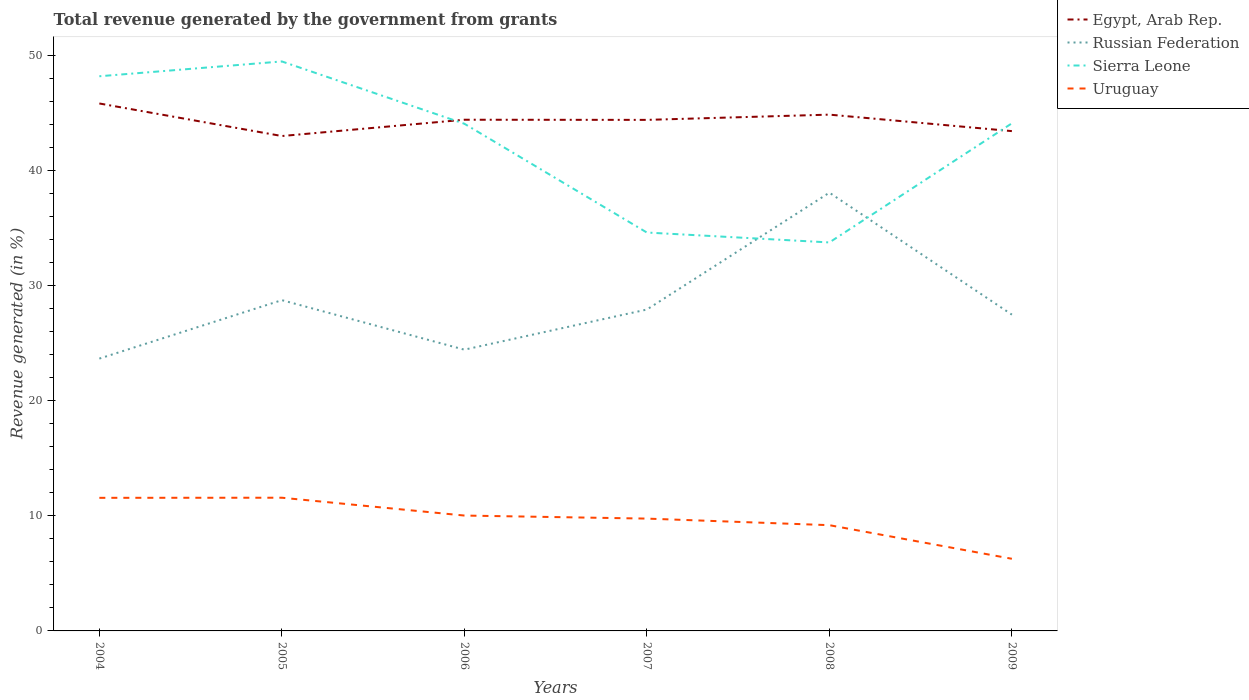Does the line corresponding to Uruguay intersect with the line corresponding to Russian Federation?
Keep it short and to the point. No. Across all years, what is the maximum total revenue generated in Egypt, Arab Rep.?
Provide a short and direct response. 43.01. What is the total total revenue generated in Sierra Leone in the graph?
Your answer should be compact. 9.45. What is the difference between the highest and the second highest total revenue generated in Sierra Leone?
Your answer should be very brief. 15.73. Is the total revenue generated in Sierra Leone strictly greater than the total revenue generated in Egypt, Arab Rep. over the years?
Ensure brevity in your answer.  No. How many lines are there?
Provide a short and direct response. 4. What is the difference between two consecutive major ticks on the Y-axis?
Your answer should be very brief. 10. Does the graph contain grids?
Provide a succinct answer. No. Where does the legend appear in the graph?
Provide a succinct answer. Top right. How many legend labels are there?
Give a very brief answer. 4. How are the legend labels stacked?
Make the answer very short. Vertical. What is the title of the graph?
Offer a very short reply. Total revenue generated by the government from grants. Does "Mali" appear as one of the legend labels in the graph?
Keep it short and to the point. No. What is the label or title of the X-axis?
Ensure brevity in your answer.  Years. What is the label or title of the Y-axis?
Your answer should be compact. Revenue generated (in %). What is the Revenue generated (in %) of Egypt, Arab Rep. in 2004?
Your response must be concise. 45.83. What is the Revenue generated (in %) of Russian Federation in 2004?
Keep it short and to the point. 23.66. What is the Revenue generated (in %) of Sierra Leone in 2004?
Provide a short and direct response. 48.2. What is the Revenue generated (in %) in Uruguay in 2004?
Offer a terse response. 11.57. What is the Revenue generated (in %) of Egypt, Arab Rep. in 2005?
Ensure brevity in your answer.  43.01. What is the Revenue generated (in %) in Russian Federation in 2005?
Your response must be concise. 28.74. What is the Revenue generated (in %) of Sierra Leone in 2005?
Your response must be concise. 49.49. What is the Revenue generated (in %) in Uruguay in 2005?
Keep it short and to the point. 11.58. What is the Revenue generated (in %) in Egypt, Arab Rep. in 2006?
Your answer should be compact. 44.42. What is the Revenue generated (in %) of Russian Federation in 2006?
Make the answer very short. 24.44. What is the Revenue generated (in %) in Sierra Leone in 2006?
Your answer should be very brief. 44.07. What is the Revenue generated (in %) of Uruguay in 2006?
Ensure brevity in your answer.  10.03. What is the Revenue generated (in %) of Egypt, Arab Rep. in 2007?
Offer a terse response. 44.41. What is the Revenue generated (in %) in Russian Federation in 2007?
Ensure brevity in your answer.  27.93. What is the Revenue generated (in %) of Sierra Leone in 2007?
Offer a terse response. 34.62. What is the Revenue generated (in %) in Uruguay in 2007?
Provide a succinct answer. 9.76. What is the Revenue generated (in %) of Egypt, Arab Rep. in 2008?
Provide a succinct answer. 44.87. What is the Revenue generated (in %) of Russian Federation in 2008?
Make the answer very short. 38.08. What is the Revenue generated (in %) in Sierra Leone in 2008?
Offer a very short reply. 33.76. What is the Revenue generated (in %) of Uruguay in 2008?
Your response must be concise. 9.19. What is the Revenue generated (in %) in Egypt, Arab Rep. in 2009?
Your answer should be compact. 43.43. What is the Revenue generated (in %) in Russian Federation in 2009?
Provide a short and direct response. 27.48. What is the Revenue generated (in %) in Sierra Leone in 2009?
Make the answer very short. 44.11. What is the Revenue generated (in %) of Uruguay in 2009?
Offer a terse response. 6.27. Across all years, what is the maximum Revenue generated (in %) of Egypt, Arab Rep.?
Ensure brevity in your answer.  45.83. Across all years, what is the maximum Revenue generated (in %) in Russian Federation?
Provide a succinct answer. 38.08. Across all years, what is the maximum Revenue generated (in %) of Sierra Leone?
Offer a very short reply. 49.49. Across all years, what is the maximum Revenue generated (in %) in Uruguay?
Provide a short and direct response. 11.58. Across all years, what is the minimum Revenue generated (in %) in Egypt, Arab Rep.?
Your response must be concise. 43.01. Across all years, what is the minimum Revenue generated (in %) of Russian Federation?
Your answer should be compact. 23.66. Across all years, what is the minimum Revenue generated (in %) in Sierra Leone?
Provide a short and direct response. 33.76. Across all years, what is the minimum Revenue generated (in %) of Uruguay?
Make the answer very short. 6.27. What is the total Revenue generated (in %) of Egypt, Arab Rep. in the graph?
Provide a succinct answer. 265.97. What is the total Revenue generated (in %) in Russian Federation in the graph?
Your answer should be very brief. 170.35. What is the total Revenue generated (in %) of Sierra Leone in the graph?
Make the answer very short. 254.25. What is the total Revenue generated (in %) in Uruguay in the graph?
Make the answer very short. 58.39. What is the difference between the Revenue generated (in %) in Egypt, Arab Rep. in 2004 and that in 2005?
Offer a terse response. 2.83. What is the difference between the Revenue generated (in %) of Russian Federation in 2004 and that in 2005?
Ensure brevity in your answer.  -5.08. What is the difference between the Revenue generated (in %) in Sierra Leone in 2004 and that in 2005?
Make the answer very short. -1.29. What is the difference between the Revenue generated (in %) in Uruguay in 2004 and that in 2005?
Make the answer very short. -0.01. What is the difference between the Revenue generated (in %) in Egypt, Arab Rep. in 2004 and that in 2006?
Your answer should be compact. 1.41. What is the difference between the Revenue generated (in %) in Russian Federation in 2004 and that in 2006?
Provide a short and direct response. -0.78. What is the difference between the Revenue generated (in %) of Sierra Leone in 2004 and that in 2006?
Offer a terse response. 4.13. What is the difference between the Revenue generated (in %) in Uruguay in 2004 and that in 2006?
Your answer should be very brief. 1.54. What is the difference between the Revenue generated (in %) of Egypt, Arab Rep. in 2004 and that in 2007?
Offer a terse response. 1.43. What is the difference between the Revenue generated (in %) of Russian Federation in 2004 and that in 2007?
Ensure brevity in your answer.  -4.26. What is the difference between the Revenue generated (in %) of Sierra Leone in 2004 and that in 2007?
Ensure brevity in your answer.  13.58. What is the difference between the Revenue generated (in %) in Uruguay in 2004 and that in 2007?
Provide a succinct answer. 1.81. What is the difference between the Revenue generated (in %) in Egypt, Arab Rep. in 2004 and that in 2008?
Your answer should be very brief. 0.97. What is the difference between the Revenue generated (in %) of Russian Federation in 2004 and that in 2008?
Your response must be concise. -14.42. What is the difference between the Revenue generated (in %) of Sierra Leone in 2004 and that in 2008?
Provide a short and direct response. 14.44. What is the difference between the Revenue generated (in %) of Uruguay in 2004 and that in 2008?
Your answer should be compact. 2.38. What is the difference between the Revenue generated (in %) of Egypt, Arab Rep. in 2004 and that in 2009?
Ensure brevity in your answer.  2.4. What is the difference between the Revenue generated (in %) in Russian Federation in 2004 and that in 2009?
Your response must be concise. -3.82. What is the difference between the Revenue generated (in %) in Sierra Leone in 2004 and that in 2009?
Keep it short and to the point. 4.09. What is the difference between the Revenue generated (in %) in Uruguay in 2004 and that in 2009?
Offer a very short reply. 5.3. What is the difference between the Revenue generated (in %) in Egypt, Arab Rep. in 2005 and that in 2006?
Ensure brevity in your answer.  -1.42. What is the difference between the Revenue generated (in %) in Russian Federation in 2005 and that in 2006?
Provide a short and direct response. 4.3. What is the difference between the Revenue generated (in %) in Sierra Leone in 2005 and that in 2006?
Give a very brief answer. 5.41. What is the difference between the Revenue generated (in %) in Uruguay in 2005 and that in 2006?
Offer a terse response. 1.55. What is the difference between the Revenue generated (in %) in Egypt, Arab Rep. in 2005 and that in 2007?
Your answer should be compact. -1.4. What is the difference between the Revenue generated (in %) in Russian Federation in 2005 and that in 2007?
Offer a very short reply. 0.82. What is the difference between the Revenue generated (in %) of Sierra Leone in 2005 and that in 2007?
Your answer should be compact. 14.87. What is the difference between the Revenue generated (in %) in Uruguay in 2005 and that in 2007?
Offer a very short reply. 1.81. What is the difference between the Revenue generated (in %) in Egypt, Arab Rep. in 2005 and that in 2008?
Your answer should be compact. -1.86. What is the difference between the Revenue generated (in %) of Russian Federation in 2005 and that in 2008?
Provide a succinct answer. -9.34. What is the difference between the Revenue generated (in %) of Sierra Leone in 2005 and that in 2008?
Provide a short and direct response. 15.73. What is the difference between the Revenue generated (in %) in Uruguay in 2005 and that in 2008?
Make the answer very short. 2.39. What is the difference between the Revenue generated (in %) of Egypt, Arab Rep. in 2005 and that in 2009?
Provide a short and direct response. -0.43. What is the difference between the Revenue generated (in %) of Russian Federation in 2005 and that in 2009?
Provide a short and direct response. 1.26. What is the difference between the Revenue generated (in %) of Sierra Leone in 2005 and that in 2009?
Provide a succinct answer. 5.38. What is the difference between the Revenue generated (in %) of Uruguay in 2005 and that in 2009?
Provide a short and direct response. 5.31. What is the difference between the Revenue generated (in %) of Egypt, Arab Rep. in 2006 and that in 2007?
Give a very brief answer. 0.01. What is the difference between the Revenue generated (in %) in Russian Federation in 2006 and that in 2007?
Keep it short and to the point. -3.49. What is the difference between the Revenue generated (in %) in Sierra Leone in 2006 and that in 2007?
Provide a short and direct response. 9.45. What is the difference between the Revenue generated (in %) in Uruguay in 2006 and that in 2007?
Keep it short and to the point. 0.27. What is the difference between the Revenue generated (in %) in Egypt, Arab Rep. in 2006 and that in 2008?
Ensure brevity in your answer.  -0.44. What is the difference between the Revenue generated (in %) of Russian Federation in 2006 and that in 2008?
Ensure brevity in your answer.  -13.64. What is the difference between the Revenue generated (in %) in Sierra Leone in 2006 and that in 2008?
Keep it short and to the point. 10.32. What is the difference between the Revenue generated (in %) of Uruguay in 2006 and that in 2008?
Provide a short and direct response. 0.84. What is the difference between the Revenue generated (in %) in Egypt, Arab Rep. in 2006 and that in 2009?
Provide a short and direct response. 0.99. What is the difference between the Revenue generated (in %) in Russian Federation in 2006 and that in 2009?
Ensure brevity in your answer.  -3.04. What is the difference between the Revenue generated (in %) of Sierra Leone in 2006 and that in 2009?
Your answer should be compact. -0.04. What is the difference between the Revenue generated (in %) in Uruguay in 2006 and that in 2009?
Your answer should be very brief. 3.76. What is the difference between the Revenue generated (in %) of Egypt, Arab Rep. in 2007 and that in 2008?
Your response must be concise. -0.46. What is the difference between the Revenue generated (in %) of Russian Federation in 2007 and that in 2008?
Make the answer very short. -10.16. What is the difference between the Revenue generated (in %) in Sierra Leone in 2007 and that in 2008?
Make the answer very short. 0.86. What is the difference between the Revenue generated (in %) of Uruguay in 2007 and that in 2008?
Provide a short and direct response. 0.57. What is the difference between the Revenue generated (in %) in Egypt, Arab Rep. in 2007 and that in 2009?
Ensure brevity in your answer.  0.98. What is the difference between the Revenue generated (in %) in Russian Federation in 2007 and that in 2009?
Offer a terse response. 0.44. What is the difference between the Revenue generated (in %) of Sierra Leone in 2007 and that in 2009?
Provide a short and direct response. -9.49. What is the difference between the Revenue generated (in %) in Uruguay in 2007 and that in 2009?
Give a very brief answer. 3.49. What is the difference between the Revenue generated (in %) of Egypt, Arab Rep. in 2008 and that in 2009?
Give a very brief answer. 1.43. What is the difference between the Revenue generated (in %) in Russian Federation in 2008 and that in 2009?
Provide a succinct answer. 10.6. What is the difference between the Revenue generated (in %) of Sierra Leone in 2008 and that in 2009?
Give a very brief answer. -10.35. What is the difference between the Revenue generated (in %) of Uruguay in 2008 and that in 2009?
Keep it short and to the point. 2.92. What is the difference between the Revenue generated (in %) of Egypt, Arab Rep. in 2004 and the Revenue generated (in %) of Russian Federation in 2005?
Your response must be concise. 17.09. What is the difference between the Revenue generated (in %) of Egypt, Arab Rep. in 2004 and the Revenue generated (in %) of Sierra Leone in 2005?
Make the answer very short. -3.65. What is the difference between the Revenue generated (in %) in Egypt, Arab Rep. in 2004 and the Revenue generated (in %) in Uruguay in 2005?
Ensure brevity in your answer.  34.26. What is the difference between the Revenue generated (in %) of Russian Federation in 2004 and the Revenue generated (in %) of Sierra Leone in 2005?
Give a very brief answer. -25.82. What is the difference between the Revenue generated (in %) in Russian Federation in 2004 and the Revenue generated (in %) in Uruguay in 2005?
Offer a terse response. 12.09. What is the difference between the Revenue generated (in %) of Sierra Leone in 2004 and the Revenue generated (in %) of Uruguay in 2005?
Give a very brief answer. 36.62. What is the difference between the Revenue generated (in %) in Egypt, Arab Rep. in 2004 and the Revenue generated (in %) in Russian Federation in 2006?
Offer a very short reply. 21.39. What is the difference between the Revenue generated (in %) in Egypt, Arab Rep. in 2004 and the Revenue generated (in %) in Sierra Leone in 2006?
Ensure brevity in your answer.  1.76. What is the difference between the Revenue generated (in %) in Egypt, Arab Rep. in 2004 and the Revenue generated (in %) in Uruguay in 2006?
Your answer should be very brief. 35.81. What is the difference between the Revenue generated (in %) in Russian Federation in 2004 and the Revenue generated (in %) in Sierra Leone in 2006?
Offer a very short reply. -20.41. What is the difference between the Revenue generated (in %) of Russian Federation in 2004 and the Revenue generated (in %) of Uruguay in 2006?
Your response must be concise. 13.64. What is the difference between the Revenue generated (in %) in Sierra Leone in 2004 and the Revenue generated (in %) in Uruguay in 2006?
Your response must be concise. 38.17. What is the difference between the Revenue generated (in %) in Egypt, Arab Rep. in 2004 and the Revenue generated (in %) in Russian Federation in 2007?
Your answer should be very brief. 17.91. What is the difference between the Revenue generated (in %) of Egypt, Arab Rep. in 2004 and the Revenue generated (in %) of Sierra Leone in 2007?
Your answer should be compact. 11.21. What is the difference between the Revenue generated (in %) of Egypt, Arab Rep. in 2004 and the Revenue generated (in %) of Uruguay in 2007?
Your response must be concise. 36.07. What is the difference between the Revenue generated (in %) in Russian Federation in 2004 and the Revenue generated (in %) in Sierra Leone in 2007?
Offer a terse response. -10.96. What is the difference between the Revenue generated (in %) of Russian Federation in 2004 and the Revenue generated (in %) of Uruguay in 2007?
Your answer should be compact. 13.9. What is the difference between the Revenue generated (in %) of Sierra Leone in 2004 and the Revenue generated (in %) of Uruguay in 2007?
Provide a short and direct response. 38.44. What is the difference between the Revenue generated (in %) of Egypt, Arab Rep. in 2004 and the Revenue generated (in %) of Russian Federation in 2008?
Make the answer very short. 7.75. What is the difference between the Revenue generated (in %) in Egypt, Arab Rep. in 2004 and the Revenue generated (in %) in Sierra Leone in 2008?
Keep it short and to the point. 12.08. What is the difference between the Revenue generated (in %) in Egypt, Arab Rep. in 2004 and the Revenue generated (in %) in Uruguay in 2008?
Keep it short and to the point. 36.64. What is the difference between the Revenue generated (in %) of Russian Federation in 2004 and the Revenue generated (in %) of Sierra Leone in 2008?
Make the answer very short. -10.09. What is the difference between the Revenue generated (in %) in Russian Federation in 2004 and the Revenue generated (in %) in Uruguay in 2008?
Offer a terse response. 14.48. What is the difference between the Revenue generated (in %) of Sierra Leone in 2004 and the Revenue generated (in %) of Uruguay in 2008?
Your answer should be very brief. 39.01. What is the difference between the Revenue generated (in %) of Egypt, Arab Rep. in 2004 and the Revenue generated (in %) of Russian Federation in 2009?
Your answer should be compact. 18.35. What is the difference between the Revenue generated (in %) in Egypt, Arab Rep. in 2004 and the Revenue generated (in %) in Sierra Leone in 2009?
Keep it short and to the point. 1.72. What is the difference between the Revenue generated (in %) of Egypt, Arab Rep. in 2004 and the Revenue generated (in %) of Uruguay in 2009?
Make the answer very short. 39.57. What is the difference between the Revenue generated (in %) in Russian Federation in 2004 and the Revenue generated (in %) in Sierra Leone in 2009?
Offer a very short reply. -20.45. What is the difference between the Revenue generated (in %) of Russian Federation in 2004 and the Revenue generated (in %) of Uruguay in 2009?
Offer a very short reply. 17.4. What is the difference between the Revenue generated (in %) in Sierra Leone in 2004 and the Revenue generated (in %) in Uruguay in 2009?
Your answer should be very brief. 41.93. What is the difference between the Revenue generated (in %) of Egypt, Arab Rep. in 2005 and the Revenue generated (in %) of Russian Federation in 2006?
Your answer should be compact. 18.56. What is the difference between the Revenue generated (in %) of Egypt, Arab Rep. in 2005 and the Revenue generated (in %) of Sierra Leone in 2006?
Ensure brevity in your answer.  -1.07. What is the difference between the Revenue generated (in %) in Egypt, Arab Rep. in 2005 and the Revenue generated (in %) in Uruguay in 2006?
Make the answer very short. 32.98. What is the difference between the Revenue generated (in %) of Russian Federation in 2005 and the Revenue generated (in %) of Sierra Leone in 2006?
Provide a succinct answer. -15.33. What is the difference between the Revenue generated (in %) of Russian Federation in 2005 and the Revenue generated (in %) of Uruguay in 2006?
Your response must be concise. 18.72. What is the difference between the Revenue generated (in %) in Sierra Leone in 2005 and the Revenue generated (in %) in Uruguay in 2006?
Keep it short and to the point. 39.46. What is the difference between the Revenue generated (in %) of Egypt, Arab Rep. in 2005 and the Revenue generated (in %) of Russian Federation in 2007?
Your response must be concise. 15.08. What is the difference between the Revenue generated (in %) of Egypt, Arab Rep. in 2005 and the Revenue generated (in %) of Sierra Leone in 2007?
Offer a very short reply. 8.39. What is the difference between the Revenue generated (in %) of Egypt, Arab Rep. in 2005 and the Revenue generated (in %) of Uruguay in 2007?
Provide a short and direct response. 33.25. What is the difference between the Revenue generated (in %) in Russian Federation in 2005 and the Revenue generated (in %) in Sierra Leone in 2007?
Offer a very short reply. -5.88. What is the difference between the Revenue generated (in %) in Russian Federation in 2005 and the Revenue generated (in %) in Uruguay in 2007?
Keep it short and to the point. 18.98. What is the difference between the Revenue generated (in %) in Sierra Leone in 2005 and the Revenue generated (in %) in Uruguay in 2007?
Offer a terse response. 39.73. What is the difference between the Revenue generated (in %) in Egypt, Arab Rep. in 2005 and the Revenue generated (in %) in Russian Federation in 2008?
Offer a terse response. 4.92. What is the difference between the Revenue generated (in %) in Egypt, Arab Rep. in 2005 and the Revenue generated (in %) in Sierra Leone in 2008?
Provide a succinct answer. 9.25. What is the difference between the Revenue generated (in %) of Egypt, Arab Rep. in 2005 and the Revenue generated (in %) of Uruguay in 2008?
Provide a short and direct response. 33.82. What is the difference between the Revenue generated (in %) in Russian Federation in 2005 and the Revenue generated (in %) in Sierra Leone in 2008?
Make the answer very short. -5.01. What is the difference between the Revenue generated (in %) of Russian Federation in 2005 and the Revenue generated (in %) of Uruguay in 2008?
Give a very brief answer. 19.55. What is the difference between the Revenue generated (in %) of Sierra Leone in 2005 and the Revenue generated (in %) of Uruguay in 2008?
Give a very brief answer. 40.3. What is the difference between the Revenue generated (in %) in Egypt, Arab Rep. in 2005 and the Revenue generated (in %) in Russian Federation in 2009?
Your answer should be very brief. 15.52. What is the difference between the Revenue generated (in %) in Egypt, Arab Rep. in 2005 and the Revenue generated (in %) in Sierra Leone in 2009?
Offer a very short reply. -1.1. What is the difference between the Revenue generated (in %) of Egypt, Arab Rep. in 2005 and the Revenue generated (in %) of Uruguay in 2009?
Offer a terse response. 36.74. What is the difference between the Revenue generated (in %) of Russian Federation in 2005 and the Revenue generated (in %) of Sierra Leone in 2009?
Offer a very short reply. -15.37. What is the difference between the Revenue generated (in %) in Russian Federation in 2005 and the Revenue generated (in %) in Uruguay in 2009?
Make the answer very short. 22.47. What is the difference between the Revenue generated (in %) of Sierra Leone in 2005 and the Revenue generated (in %) of Uruguay in 2009?
Ensure brevity in your answer.  43.22. What is the difference between the Revenue generated (in %) in Egypt, Arab Rep. in 2006 and the Revenue generated (in %) in Russian Federation in 2007?
Your response must be concise. 16.49. What is the difference between the Revenue generated (in %) of Egypt, Arab Rep. in 2006 and the Revenue generated (in %) of Sierra Leone in 2007?
Provide a succinct answer. 9.8. What is the difference between the Revenue generated (in %) in Egypt, Arab Rep. in 2006 and the Revenue generated (in %) in Uruguay in 2007?
Give a very brief answer. 34.66. What is the difference between the Revenue generated (in %) in Russian Federation in 2006 and the Revenue generated (in %) in Sierra Leone in 2007?
Give a very brief answer. -10.18. What is the difference between the Revenue generated (in %) in Russian Federation in 2006 and the Revenue generated (in %) in Uruguay in 2007?
Make the answer very short. 14.68. What is the difference between the Revenue generated (in %) of Sierra Leone in 2006 and the Revenue generated (in %) of Uruguay in 2007?
Ensure brevity in your answer.  34.31. What is the difference between the Revenue generated (in %) of Egypt, Arab Rep. in 2006 and the Revenue generated (in %) of Russian Federation in 2008?
Ensure brevity in your answer.  6.34. What is the difference between the Revenue generated (in %) in Egypt, Arab Rep. in 2006 and the Revenue generated (in %) in Sierra Leone in 2008?
Give a very brief answer. 10.66. What is the difference between the Revenue generated (in %) of Egypt, Arab Rep. in 2006 and the Revenue generated (in %) of Uruguay in 2008?
Make the answer very short. 35.23. What is the difference between the Revenue generated (in %) in Russian Federation in 2006 and the Revenue generated (in %) in Sierra Leone in 2008?
Ensure brevity in your answer.  -9.32. What is the difference between the Revenue generated (in %) in Russian Federation in 2006 and the Revenue generated (in %) in Uruguay in 2008?
Ensure brevity in your answer.  15.25. What is the difference between the Revenue generated (in %) in Sierra Leone in 2006 and the Revenue generated (in %) in Uruguay in 2008?
Ensure brevity in your answer.  34.88. What is the difference between the Revenue generated (in %) of Egypt, Arab Rep. in 2006 and the Revenue generated (in %) of Russian Federation in 2009?
Your answer should be compact. 16.94. What is the difference between the Revenue generated (in %) in Egypt, Arab Rep. in 2006 and the Revenue generated (in %) in Sierra Leone in 2009?
Keep it short and to the point. 0.31. What is the difference between the Revenue generated (in %) of Egypt, Arab Rep. in 2006 and the Revenue generated (in %) of Uruguay in 2009?
Give a very brief answer. 38.15. What is the difference between the Revenue generated (in %) of Russian Federation in 2006 and the Revenue generated (in %) of Sierra Leone in 2009?
Give a very brief answer. -19.67. What is the difference between the Revenue generated (in %) in Russian Federation in 2006 and the Revenue generated (in %) in Uruguay in 2009?
Keep it short and to the point. 18.17. What is the difference between the Revenue generated (in %) in Sierra Leone in 2006 and the Revenue generated (in %) in Uruguay in 2009?
Provide a succinct answer. 37.81. What is the difference between the Revenue generated (in %) of Egypt, Arab Rep. in 2007 and the Revenue generated (in %) of Russian Federation in 2008?
Offer a terse response. 6.33. What is the difference between the Revenue generated (in %) in Egypt, Arab Rep. in 2007 and the Revenue generated (in %) in Sierra Leone in 2008?
Ensure brevity in your answer.  10.65. What is the difference between the Revenue generated (in %) of Egypt, Arab Rep. in 2007 and the Revenue generated (in %) of Uruguay in 2008?
Make the answer very short. 35.22. What is the difference between the Revenue generated (in %) in Russian Federation in 2007 and the Revenue generated (in %) in Sierra Leone in 2008?
Your answer should be compact. -5.83. What is the difference between the Revenue generated (in %) of Russian Federation in 2007 and the Revenue generated (in %) of Uruguay in 2008?
Keep it short and to the point. 18.74. What is the difference between the Revenue generated (in %) in Sierra Leone in 2007 and the Revenue generated (in %) in Uruguay in 2008?
Offer a very short reply. 25.43. What is the difference between the Revenue generated (in %) of Egypt, Arab Rep. in 2007 and the Revenue generated (in %) of Russian Federation in 2009?
Your response must be concise. 16.92. What is the difference between the Revenue generated (in %) of Egypt, Arab Rep. in 2007 and the Revenue generated (in %) of Sierra Leone in 2009?
Offer a terse response. 0.3. What is the difference between the Revenue generated (in %) in Egypt, Arab Rep. in 2007 and the Revenue generated (in %) in Uruguay in 2009?
Your response must be concise. 38.14. What is the difference between the Revenue generated (in %) in Russian Federation in 2007 and the Revenue generated (in %) in Sierra Leone in 2009?
Your answer should be compact. -16.18. What is the difference between the Revenue generated (in %) in Russian Federation in 2007 and the Revenue generated (in %) in Uruguay in 2009?
Your answer should be compact. 21.66. What is the difference between the Revenue generated (in %) of Sierra Leone in 2007 and the Revenue generated (in %) of Uruguay in 2009?
Offer a terse response. 28.35. What is the difference between the Revenue generated (in %) in Egypt, Arab Rep. in 2008 and the Revenue generated (in %) in Russian Federation in 2009?
Give a very brief answer. 17.38. What is the difference between the Revenue generated (in %) of Egypt, Arab Rep. in 2008 and the Revenue generated (in %) of Sierra Leone in 2009?
Ensure brevity in your answer.  0.75. What is the difference between the Revenue generated (in %) of Egypt, Arab Rep. in 2008 and the Revenue generated (in %) of Uruguay in 2009?
Make the answer very short. 38.6. What is the difference between the Revenue generated (in %) of Russian Federation in 2008 and the Revenue generated (in %) of Sierra Leone in 2009?
Give a very brief answer. -6.03. What is the difference between the Revenue generated (in %) of Russian Federation in 2008 and the Revenue generated (in %) of Uruguay in 2009?
Keep it short and to the point. 31.82. What is the difference between the Revenue generated (in %) of Sierra Leone in 2008 and the Revenue generated (in %) of Uruguay in 2009?
Your answer should be compact. 27.49. What is the average Revenue generated (in %) in Egypt, Arab Rep. per year?
Your answer should be compact. 44.33. What is the average Revenue generated (in %) in Russian Federation per year?
Keep it short and to the point. 28.39. What is the average Revenue generated (in %) of Sierra Leone per year?
Your answer should be compact. 42.37. What is the average Revenue generated (in %) in Uruguay per year?
Your answer should be compact. 9.73. In the year 2004, what is the difference between the Revenue generated (in %) of Egypt, Arab Rep. and Revenue generated (in %) of Russian Federation?
Your response must be concise. 22.17. In the year 2004, what is the difference between the Revenue generated (in %) in Egypt, Arab Rep. and Revenue generated (in %) in Sierra Leone?
Provide a succinct answer. -2.37. In the year 2004, what is the difference between the Revenue generated (in %) in Egypt, Arab Rep. and Revenue generated (in %) in Uruguay?
Your answer should be compact. 34.27. In the year 2004, what is the difference between the Revenue generated (in %) of Russian Federation and Revenue generated (in %) of Sierra Leone?
Your answer should be compact. -24.53. In the year 2004, what is the difference between the Revenue generated (in %) of Russian Federation and Revenue generated (in %) of Uruguay?
Your answer should be compact. 12.1. In the year 2004, what is the difference between the Revenue generated (in %) in Sierra Leone and Revenue generated (in %) in Uruguay?
Ensure brevity in your answer.  36.63. In the year 2005, what is the difference between the Revenue generated (in %) of Egypt, Arab Rep. and Revenue generated (in %) of Russian Federation?
Your answer should be very brief. 14.26. In the year 2005, what is the difference between the Revenue generated (in %) in Egypt, Arab Rep. and Revenue generated (in %) in Sierra Leone?
Your answer should be compact. -6.48. In the year 2005, what is the difference between the Revenue generated (in %) in Egypt, Arab Rep. and Revenue generated (in %) in Uruguay?
Ensure brevity in your answer.  31.43. In the year 2005, what is the difference between the Revenue generated (in %) of Russian Federation and Revenue generated (in %) of Sierra Leone?
Make the answer very short. -20.74. In the year 2005, what is the difference between the Revenue generated (in %) of Russian Federation and Revenue generated (in %) of Uruguay?
Offer a terse response. 17.17. In the year 2005, what is the difference between the Revenue generated (in %) of Sierra Leone and Revenue generated (in %) of Uruguay?
Your answer should be compact. 37.91. In the year 2006, what is the difference between the Revenue generated (in %) of Egypt, Arab Rep. and Revenue generated (in %) of Russian Federation?
Make the answer very short. 19.98. In the year 2006, what is the difference between the Revenue generated (in %) of Egypt, Arab Rep. and Revenue generated (in %) of Sierra Leone?
Offer a very short reply. 0.35. In the year 2006, what is the difference between the Revenue generated (in %) in Egypt, Arab Rep. and Revenue generated (in %) in Uruguay?
Offer a terse response. 34.4. In the year 2006, what is the difference between the Revenue generated (in %) of Russian Federation and Revenue generated (in %) of Sierra Leone?
Make the answer very short. -19.63. In the year 2006, what is the difference between the Revenue generated (in %) of Russian Federation and Revenue generated (in %) of Uruguay?
Provide a short and direct response. 14.42. In the year 2006, what is the difference between the Revenue generated (in %) in Sierra Leone and Revenue generated (in %) in Uruguay?
Give a very brief answer. 34.05. In the year 2007, what is the difference between the Revenue generated (in %) in Egypt, Arab Rep. and Revenue generated (in %) in Russian Federation?
Provide a succinct answer. 16.48. In the year 2007, what is the difference between the Revenue generated (in %) in Egypt, Arab Rep. and Revenue generated (in %) in Sierra Leone?
Provide a short and direct response. 9.79. In the year 2007, what is the difference between the Revenue generated (in %) of Egypt, Arab Rep. and Revenue generated (in %) of Uruguay?
Ensure brevity in your answer.  34.65. In the year 2007, what is the difference between the Revenue generated (in %) of Russian Federation and Revenue generated (in %) of Sierra Leone?
Keep it short and to the point. -6.69. In the year 2007, what is the difference between the Revenue generated (in %) in Russian Federation and Revenue generated (in %) in Uruguay?
Ensure brevity in your answer.  18.17. In the year 2007, what is the difference between the Revenue generated (in %) in Sierra Leone and Revenue generated (in %) in Uruguay?
Ensure brevity in your answer.  24.86. In the year 2008, what is the difference between the Revenue generated (in %) of Egypt, Arab Rep. and Revenue generated (in %) of Russian Federation?
Your answer should be very brief. 6.78. In the year 2008, what is the difference between the Revenue generated (in %) in Egypt, Arab Rep. and Revenue generated (in %) in Sierra Leone?
Your answer should be compact. 11.11. In the year 2008, what is the difference between the Revenue generated (in %) in Egypt, Arab Rep. and Revenue generated (in %) in Uruguay?
Keep it short and to the point. 35.68. In the year 2008, what is the difference between the Revenue generated (in %) of Russian Federation and Revenue generated (in %) of Sierra Leone?
Ensure brevity in your answer.  4.33. In the year 2008, what is the difference between the Revenue generated (in %) of Russian Federation and Revenue generated (in %) of Uruguay?
Your response must be concise. 28.89. In the year 2008, what is the difference between the Revenue generated (in %) in Sierra Leone and Revenue generated (in %) in Uruguay?
Keep it short and to the point. 24.57. In the year 2009, what is the difference between the Revenue generated (in %) of Egypt, Arab Rep. and Revenue generated (in %) of Russian Federation?
Keep it short and to the point. 15.95. In the year 2009, what is the difference between the Revenue generated (in %) in Egypt, Arab Rep. and Revenue generated (in %) in Sierra Leone?
Your answer should be very brief. -0.68. In the year 2009, what is the difference between the Revenue generated (in %) in Egypt, Arab Rep. and Revenue generated (in %) in Uruguay?
Your answer should be very brief. 37.16. In the year 2009, what is the difference between the Revenue generated (in %) of Russian Federation and Revenue generated (in %) of Sierra Leone?
Your answer should be compact. -16.63. In the year 2009, what is the difference between the Revenue generated (in %) of Russian Federation and Revenue generated (in %) of Uruguay?
Provide a succinct answer. 21.22. In the year 2009, what is the difference between the Revenue generated (in %) in Sierra Leone and Revenue generated (in %) in Uruguay?
Your answer should be very brief. 37.84. What is the ratio of the Revenue generated (in %) in Egypt, Arab Rep. in 2004 to that in 2005?
Your response must be concise. 1.07. What is the ratio of the Revenue generated (in %) in Russian Federation in 2004 to that in 2005?
Make the answer very short. 0.82. What is the ratio of the Revenue generated (in %) of Uruguay in 2004 to that in 2005?
Your answer should be very brief. 1. What is the ratio of the Revenue generated (in %) of Egypt, Arab Rep. in 2004 to that in 2006?
Provide a short and direct response. 1.03. What is the ratio of the Revenue generated (in %) in Russian Federation in 2004 to that in 2006?
Offer a very short reply. 0.97. What is the ratio of the Revenue generated (in %) of Sierra Leone in 2004 to that in 2006?
Offer a terse response. 1.09. What is the ratio of the Revenue generated (in %) in Uruguay in 2004 to that in 2006?
Your answer should be very brief. 1.15. What is the ratio of the Revenue generated (in %) of Egypt, Arab Rep. in 2004 to that in 2007?
Ensure brevity in your answer.  1.03. What is the ratio of the Revenue generated (in %) of Russian Federation in 2004 to that in 2007?
Keep it short and to the point. 0.85. What is the ratio of the Revenue generated (in %) in Sierra Leone in 2004 to that in 2007?
Keep it short and to the point. 1.39. What is the ratio of the Revenue generated (in %) in Uruguay in 2004 to that in 2007?
Give a very brief answer. 1.19. What is the ratio of the Revenue generated (in %) in Egypt, Arab Rep. in 2004 to that in 2008?
Your response must be concise. 1.02. What is the ratio of the Revenue generated (in %) in Russian Federation in 2004 to that in 2008?
Make the answer very short. 0.62. What is the ratio of the Revenue generated (in %) of Sierra Leone in 2004 to that in 2008?
Keep it short and to the point. 1.43. What is the ratio of the Revenue generated (in %) of Uruguay in 2004 to that in 2008?
Offer a terse response. 1.26. What is the ratio of the Revenue generated (in %) in Egypt, Arab Rep. in 2004 to that in 2009?
Make the answer very short. 1.06. What is the ratio of the Revenue generated (in %) in Russian Federation in 2004 to that in 2009?
Make the answer very short. 0.86. What is the ratio of the Revenue generated (in %) in Sierra Leone in 2004 to that in 2009?
Keep it short and to the point. 1.09. What is the ratio of the Revenue generated (in %) in Uruguay in 2004 to that in 2009?
Provide a short and direct response. 1.84. What is the ratio of the Revenue generated (in %) of Egypt, Arab Rep. in 2005 to that in 2006?
Your answer should be very brief. 0.97. What is the ratio of the Revenue generated (in %) of Russian Federation in 2005 to that in 2006?
Provide a short and direct response. 1.18. What is the ratio of the Revenue generated (in %) in Sierra Leone in 2005 to that in 2006?
Keep it short and to the point. 1.12. What is the ratio of the Revenue generated (in %) in Uruguay in 2005 to that in 2006?
Keep it short and to the point. 1.15. What is the ratio of the Revenue generated (in %) of Egypt, Arab Rep. in 2005 to that in 2007?
Your response must be concise. 0.97. What is the ratio of the Revenue generated (in %) of Russian Federation in 2005 to that in 2007?
Provide a succinct answer. 1.03. What is the ratio of the Revenue generated (in %) in Sierra Leone in 2005 to that in 2007?
Ensure brevity in your answer.  1.43. What is the ratio of the Revenue generated (in %) of Uruguay in 2005 to that in 2007?
Provide a succinct answer. 1.19. What is the ratio of the Revenue generated (in %) of Egypt, Arab Rep. in 2005 to that in 2008?
Provide a short and direct response. 0.96. What is the ratio of the Revenue generated (in %) in Russian Federation in 2005 to that in 2008?
Provide a succinct answer. 0.75. What is the ratio of the Revenue generated (in %) in Sierra Leone in 2005 to that in 2008?
Make the answer very short. 1.47. What is the ratio of the Revenue generated (in %) in Uruguay in 2005 to that in 2008?
Offer a very short reply. 1.26. What is the ratio of the Revenue generated (in %) of Egypt, Arab Rep. in 2005 to that in 2009?
Your answer should be very brief. 0.99. What is the ratio of the Revenue generated (in %) of Russian Federation in 2005 to that in 2009?
Your answer should be compact. 1.05. What is the ratio of the Revenue generated (in %) in Sierra Leone in 2005 to that in 2009?
Provide a succinct answer. 1.12. What is the ratio of the Revenue generated (in %) of Uruguay in 2005 to that in 2009?
Ensure brevity in your answer.  1.85. What is the ratio of the Revenue generated (in %) in Egypt, Arab Rep. in 2006 to that in 2007?
Offer a very short reply. 1. What is the ratio of the Revenue generated (in %) of Russian Federation in 2006 to that in 2007?
Keep it short and to the point. 0.88. What is the ratio of the Revenue generated (in %) in Sierra Leone in 2006 to that in 2007?
Make the answer very short. 1.27. What is the ratio of the Revenue generated (in %) in Uruguay in 2006 to that in 2007?
Your response must be concise. 1.03. What is the ratio of the Revenue generated (in %) of Egypt, Arab Rep. in 2006 to that in 2008?
Make the answer very short. 0.99. What is the ratio of the Revenue generated (in %) of Russian Federation in 2006 to that in 2008?
Offer a terse response. 0.64. What is the ratio of the Revenue generated (in %) of Sierra Leone in 2006 to that in 2008?
Keep it short and to the point. 1.31. What is the ratio of the Revenue generated (in %) in Uruguay in 2006 to that in 2008?
Ensure brevity in your answer.  1.09. What is the ratio of the Revenue generated (in %) in Egypt, Arab Rep. in 2006 to that in 2009?
Keep it short and to the point. 1.02. What is the ratio of the Revenue generated (in %) of Russian Federation in 2006 to that in 2009?
Keep it short and to the point. 0.89. What is the ratio of the Revenue generated (in %) in Sierra Leone in 2006 to that in 2009?
Your answer should be compact. 1. What is the ratio of the Revenue generated (in %) in Uruguay in 2006 to that in 2009?
Make the answer very short. 1.6. What is the ratio of the Revenue generated (in %) in Egypt, Arab Rep. in 2007 to that in 2008?
Your answer should be very brief. 0.99. What is the ratio of the Revenue generated (in %) in Russian Federation in 2007 to that in 2008?
Your answer should be compact. 0.73. What is the ratio of the Revenue generated (in %) of Sierra Leone in 2007 to that in 2008?
Give a very brief answer. 1.03. What is the ratio of the Revenue generated (in %) of Uruguay in 2007 to that in 2008?
Make the answer very short. 1.06. What is the ratio of the Revenue generated (in %) in Egypt, Arab Rep. in 2007 to that in 2009?
Keep it short and to the point. 1.02. What is the ratio of the Revenue generated (in %) of Russian Federation in 2007 to that in 2009?
Provide a succinct answer. 1.02. What is the ratio of the Revenue generated (in %) of Sierra Leone in 2007 to that in 2009?
Provide a succinct answer. 0.78. What is the ratio of the Revenue generated (in %) of Uruguay in 2007 to that in 2009?
Make the answer very short. 1.56. What is the ratio of the Revenue generated (in %) of Egypt, Arab Rep. in 2008 to that in 2009?
Give a very brief answer. 1.03. What is the ratio of the Revenue generated (in %) of Russian Federation in 2008 to that in 2009?
Offer a terse response. 1.39. What is the ratio of the Revenue generated (in %) of Sierra Leone in 2008 to that in 2009?
Your response must be concise. 0.77. What is the ratio of the Revenue generated (in %) of Uruguay in 2008 to that in 2009?
Offer a very short reply. 1.47. What is the difference between the highest and the second highest Revenue generated (in %) in Egypt, Arab Rep.?
Provide a succinct answer. 0.97. What is the difference between the highest and the second highest Revenue generated (in %) of Russian Federation?
Make the answer very short. 9.34. What is the difference between the highest and the second highest Revenue generated (in %) in Sierra Leone?
Ensure brevity in your answer.  1.29. What is the difference between the highest and the second highest Revenue generated (in %) of Uruguay?
Give a very brief answer. 0.01. What is the difference between the highest and the lowest Revenue generated (in %) of Egypt, Arab Rep.?
Provide a succinct answer. 2.83. What is the difference between the highest and the lowest Revenue generated (in %) of Russian Federation?
Your answer should be very brief. 14.42. What is the difference between the highest and the lowest Revenue generated (in %) in Sierra Leone?
Offer a terse response. 15.73. What is the difference between the highest and the lowest Revenue generated (in %) of Uruguay?
Offer a terse response. 5.31. 